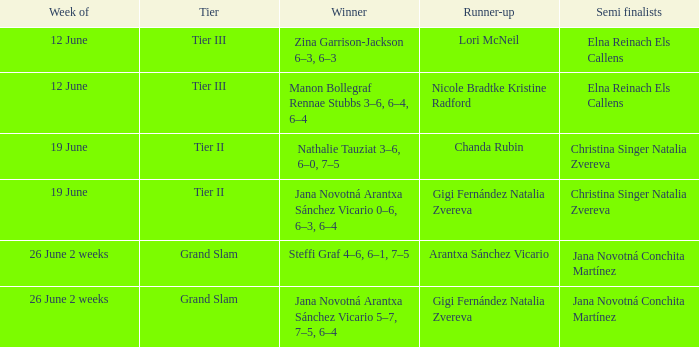When the runner-up is listed as Gigi Fernández Natalia Zvereva and the week is 26 June 2 weeks, who are the semi finalists? Jana Novotná Conchita Martínez. 